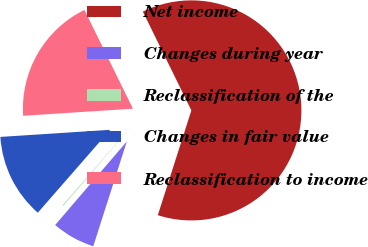Convert chart. <chart><loc_0><loc_0><loc_500><loc_500><pie_chart><fcel>Net income<fcel>Changes during year<fcel>Reclassification of the<fcel>Changes in fair value<fcel>Reclassification to income<nl><fcel>62.2%<fcel>6.35%<fcel>0.14%<fcel>12.55%<fcel>18.76%<nl></chart> 